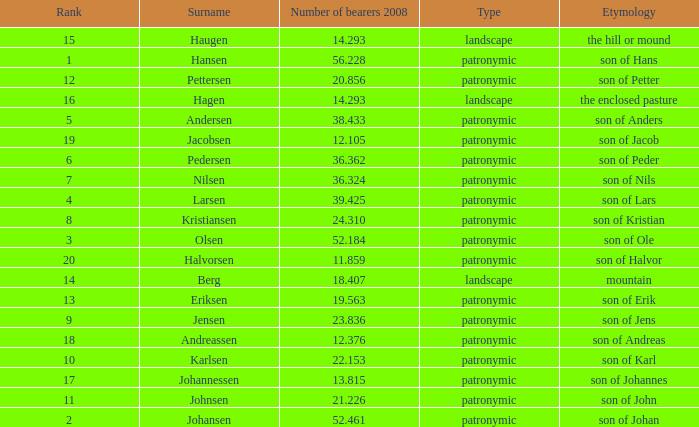What is Etymology, when Rank is 14? Mountain. 